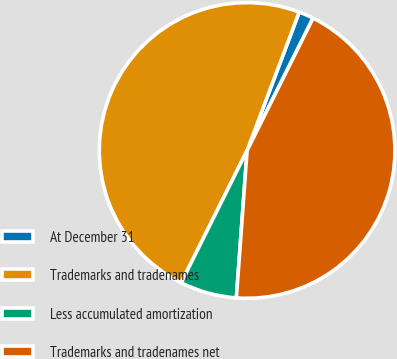<chart> <loc_0><loc_0><loc_500><loc_500><pie_chart><fcel>At December 31<fcel>Trademarks and tradenames<fcel>Less accumulated amortization<fcel>Trademarks and tradenames net<nl><fcel>1.63%<fcel>48.37%<fcel>6.2%<fcel>43.8%<nl></chart> 